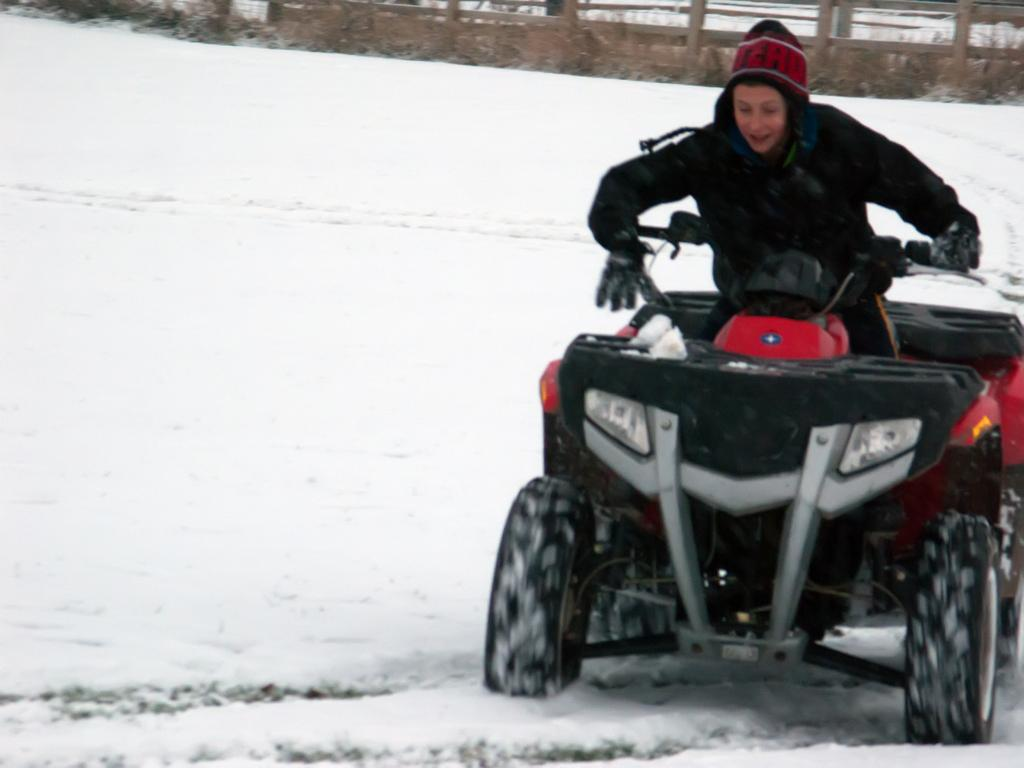What is the main subject of the image? There is a vehicle in the image. What is the terrain like where the vehicle is located? The vehicle is on snow. Can you describe the person in the image? There is a person wearing clothes in the top right of the image. What is the purpose of the fence in the image? There is a fence at the top of the image, which may serve as a boundary or barrier. What type of duck can be seen swimming in the snow in the image? There is no duck present in the image; the vehicle is on snow, but there is no indication of a duck or any water for it to swim in. 